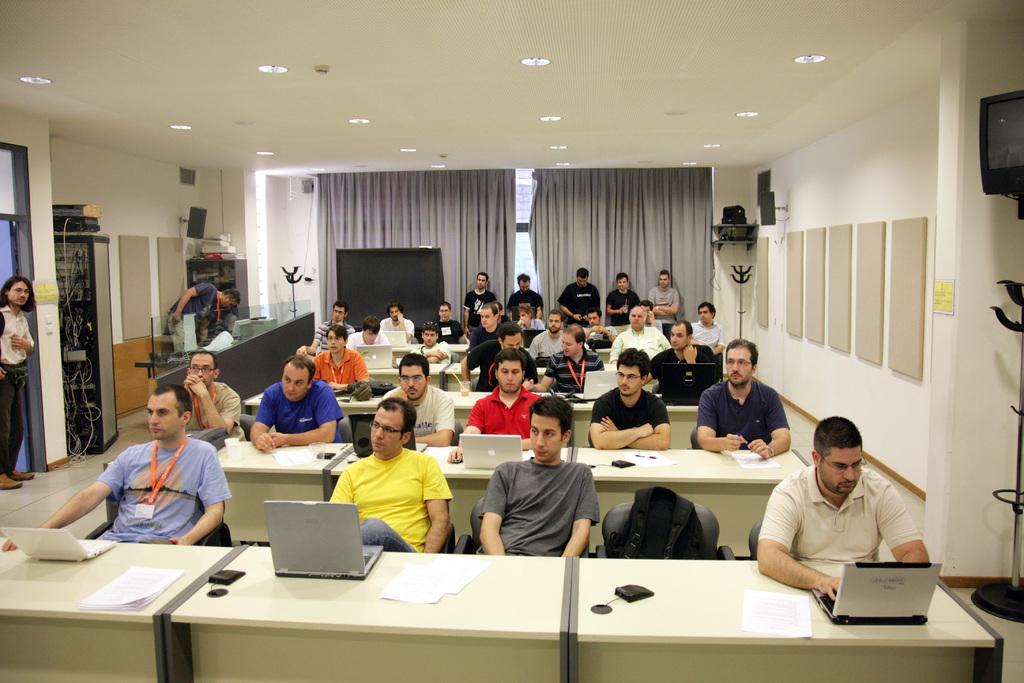Could you give a brief overview of what you see in this image? In this image we can see many people sitting. Few people are standing. Some are wearing tags. And there are tables. On the table there are laptops, papers and few other items. In the back there are curtains. On the ceiling there are lights. On the left side there is an electronic machine with wires. Also there are few other items. On the wall there are boards and speakers. In the back there is a screen and cupboard with some items. On the right side there is a device on a stand. 